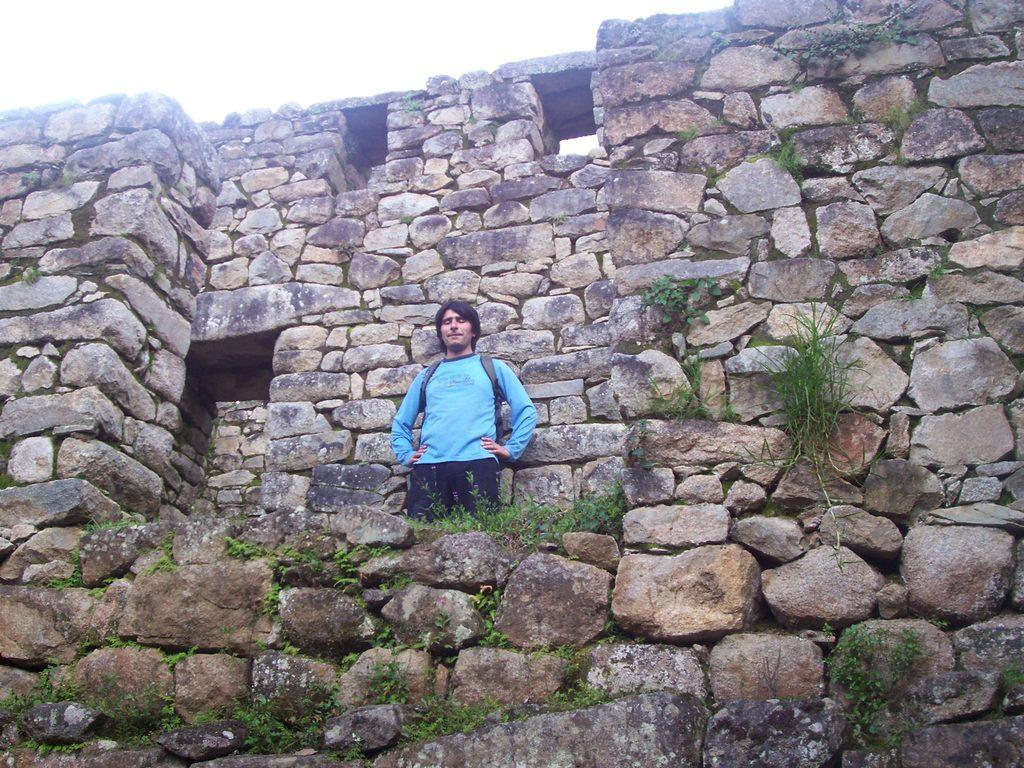Who or what is present in the image? There is a person in the image. What is the person standing on? The person is on rocks. What can be seen in the background of the image? There is a big rock wall and other plants visible in the background. What type of paper is the person holding in the image? There is no paper present in the image; the person is standing on rocks with a rock wall and plants visible in the background. 